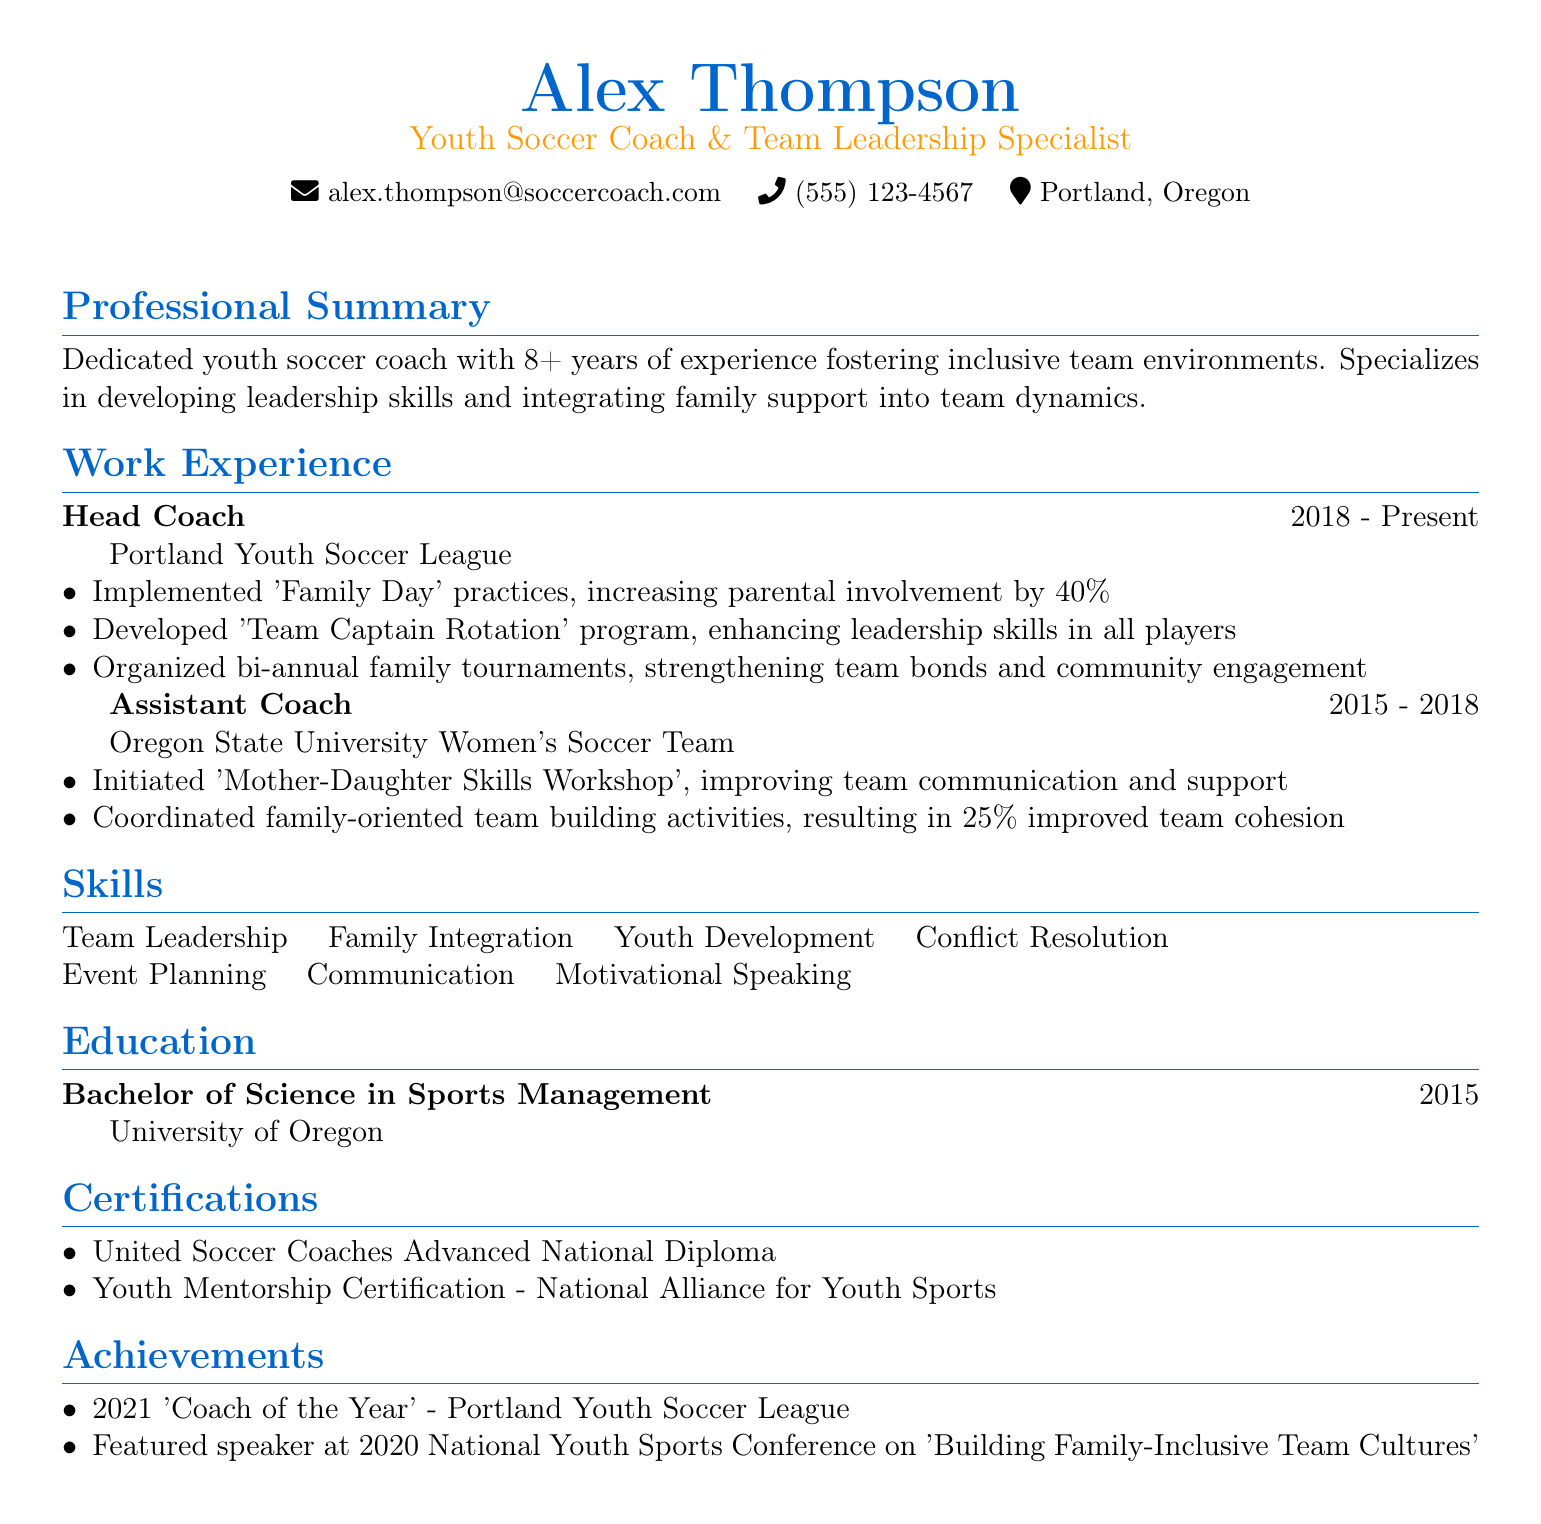what is the name of the individual? The name is presented at the top of the document as the main title.
Answer: Alex Thompson what is the title listed in the resume? The title is stated below the name, describing the individual's profession.
Answer: Youth Soccer Coach & Team Leadership Specialist how many years of experience does Alex have? The professional summary provides the total years of experience.
Answer: 8+ what is the duration of Alex's current position? The duration is indicated under the work experience section for the Head Coach role.
Answer: 2018 - Present what program was developed to enhance leadership skills? The specific program mentioned in the achievements for the Head Coach position addresses leadership.
Answer: Team Captain Rotation which family-oriented workshop did the assistant coach initiate? The document specifies the name of the workshop initiated by the assistant coach.
Answer: Mother-Daughter Skills Workshop what percentage increase in parental involvement did 'Family Day' practices achieve? The related achievement under the Head Coach position indicates the improved involvement percentage.
Answer: 40% which university did Alex graduate from? The name of the educational institution is provided in the education section.
Answer: University of Oregon what recognition did Alex receive in 2021? The achievements section lists this award as part of highlight accomplishments.
Answer: Coach of the Year what was the topic of Alex's featured speech in 2020? The achievements section reveals the subject of the speech presented at the conference.
Answer: Building Family-Inclusive Team Cultures 